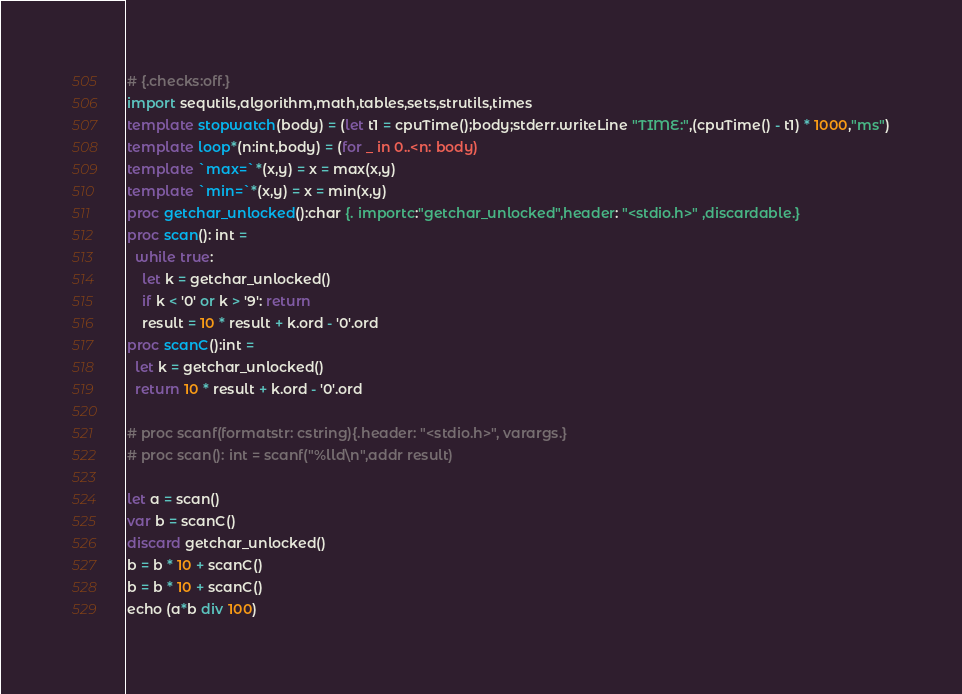Convert code to text. <code><loc_0><loc_0><loc_500><loc_500><_Nim_># {.checks:off.}
import sequtils,algorithm,math,tables,sets,strutils,times
template stopwatch(body) = (let t1 = cpuTime();body;stderr.writeLine "TIME:",(cpuTime() - t1) * 1000,"ms")
template loop*(n:int,body) = (for _ in 0..<n: body)
template `max=`*(x,y) = x = max(x,y)
template `min=`*(x,y) = x = min(x,y)
proc getchar_unlocked():char {. importc:"getchar_unlocked",header: "<stdio.h>" ,discardable.}
proc scan(): int =
  while true:
    let k = getchar_unlocked()
    if k < '0' or k > '9': return
    result = 10 * result + k.ord - '0'.ord
proc scanC():int =
  let k = getchar_unlocked()
  return 10 * result + k.ord - '0'.ord

# proc scanf(formatstr: cstring){.header: "<stdio.h>", varargs.}
# proc scan(): int = scanf("%lld\n",addr result)

let a = scan()
var b = scanC()
discard getchar_unlocked()
b = b * 10 + scanC()
b = b * 10 + scanC()
echo (a*b div 100)
</code> 